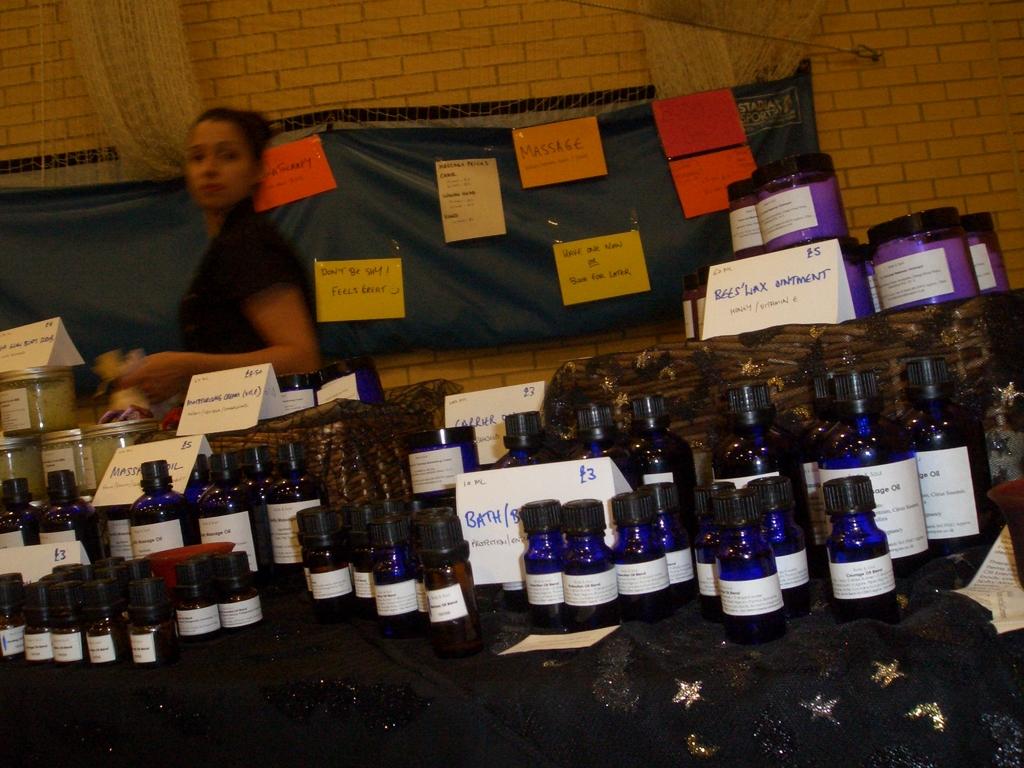What does the orange poster say?
Provide a short and direct response. Massage. What word is on the white card in the front?
Offer a very short reply. Bath. 